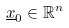<formula> <loc_0><loc_0><loc_500><loc_500>\underline { x } _ { 0 } \in \mathbb { R } ^ { n }</formula> 